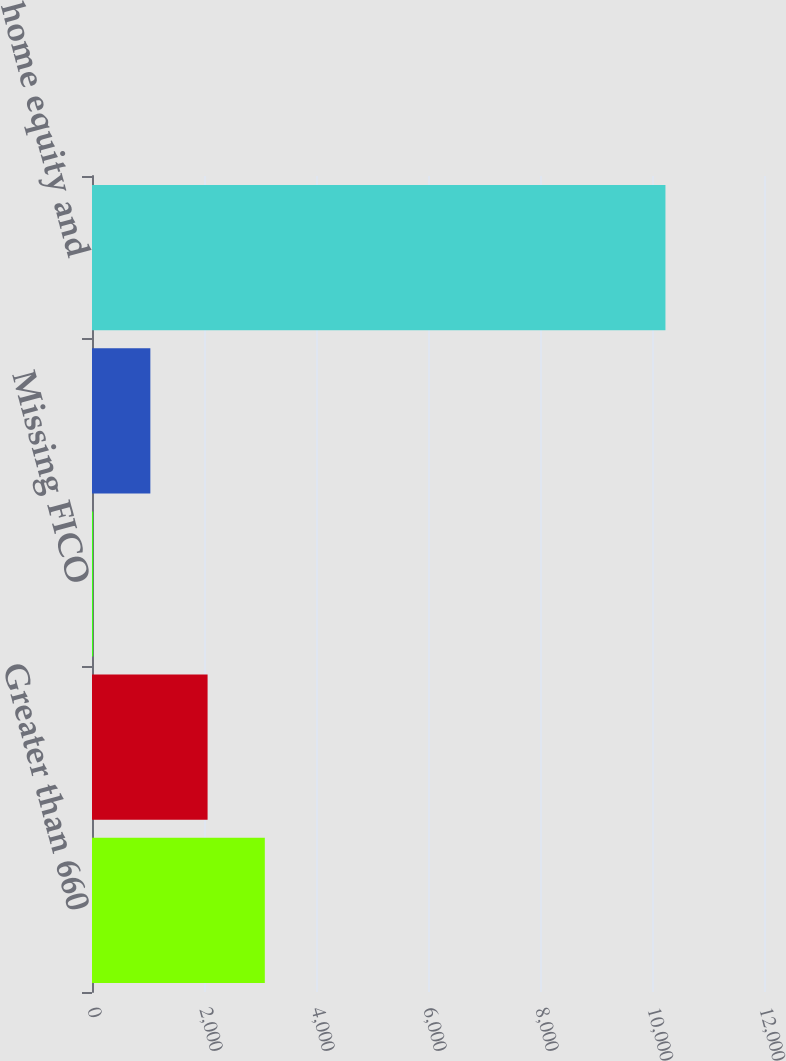Convert chart to OTSL. <chart><loc_0><loc_0><loc_500><loc_500><bar_chart><fcel>Greater than 660<fcel>Less than or equal to 660 (d)<fcel>Missing FICO<fcel>Less than or equal to 660<fcel>Total home equity and<nl><fcel>3086<fcel>2064<fcel>20<fcel>1042<fcel>10240<nl></chart> 